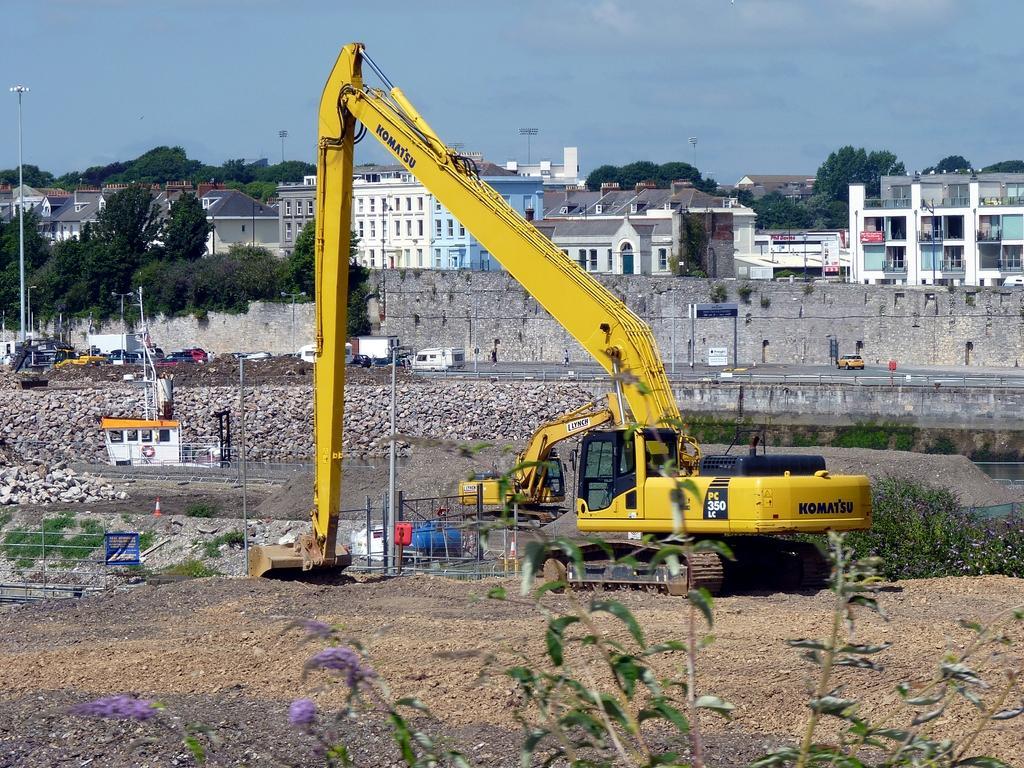Describe this image in one or two sentences. In this picture we can see plants and flowers at the bottom, there are some stones, a crane, grass, a wall, vehicles, poles, a board and trees in the middle, in the background there are some buildings and trees, we can see the sky at the top of the picture. 